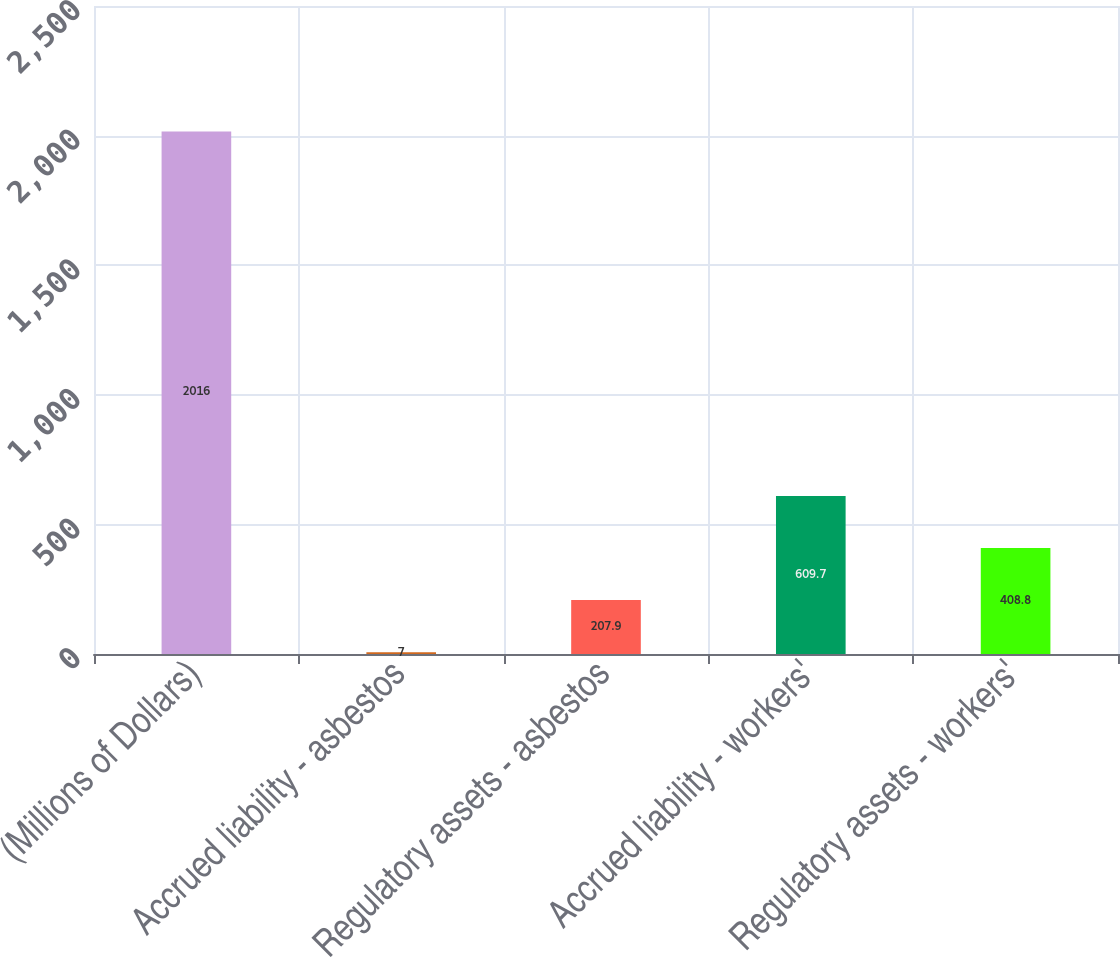Convert chart. <chart><loc_0><loc_0><loc_500><loc_500><bar_chart><fcel>(Millions of Dollars)<fcel>Accrued liability - asbestos<fcel>Regulatory assets - asbestos<fcel>Accrued liability - workers'<fcel>Regulatory assets - workers'<nl><fcel>2016<fcel>7<fcel>207.9<fcel>609.7<fcel>408.8<nl></chart> 